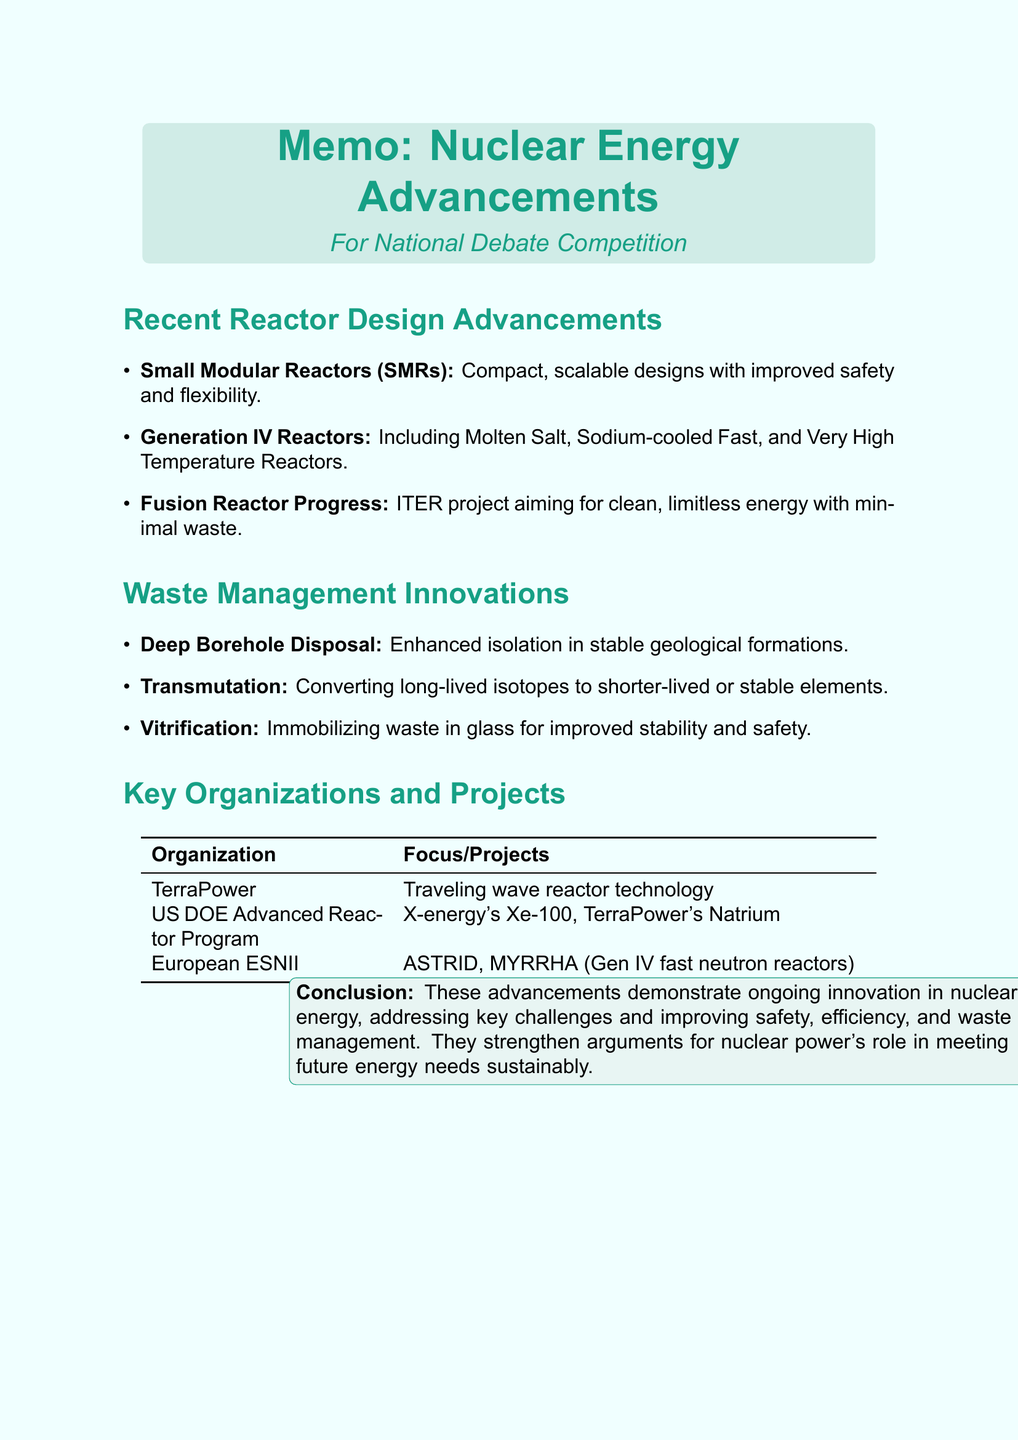What is the title of the memo? The title provides the main subject and focus of the document, which is "Recent Technological Advancements in Nuclear Reactor Design and Waste Management."
Answer: Recent Technological Advancements in Nuclear Reactor Design and Waste Management What are the three types of reactors mentioned under advancements? The types of reactors listed are specifically categorized in the document under advancements in reactor design, which includes Small Modular Reactors, Generation IV Reactors, and Fusion Reactors.
Answer: Small Modular Reactors, Generation IV Reactors, Fusion Reactors What is the notable project in Fusion Reactor Progress? This project represents significant advancements in fusion energy and is mentioned explicitly in the document as an example.
Answer: ITER How deep can boreholes be drilled for waste disposal? The document specifies the depth to which boreholes can be drilled for the disposal of nuclear waste, indicating a considerable depth.
Answer: up to 5km What focus does TerraPower have? The document outlines the focus of TerraPower in developing specific technologies related to nuclear energy, highlighting its initiative in traveling wave reactor technology.
Answer: Developing traveling wave reactor technology What is the primary goal of the US Department of Energy's Advanced Reactor Demonstration Program? The document describes the primary objective of this program in accelerating the deployment of important nuclear technologies in the US.
Answer: Accelerate deployment of advanced nuclear reactors What is a benefit of transmutation technology? One key benefit is mentioned in the document, showing its potential to improve waste management in nuclear energy.
Answer: Reduced long-term radioactivity of waste What is one advantage of Small Modular Reactors? The document lists several benefits, focusing on a specific improvement over traditional reactors regarding time and costs.
Answer: Reduced construction costs 